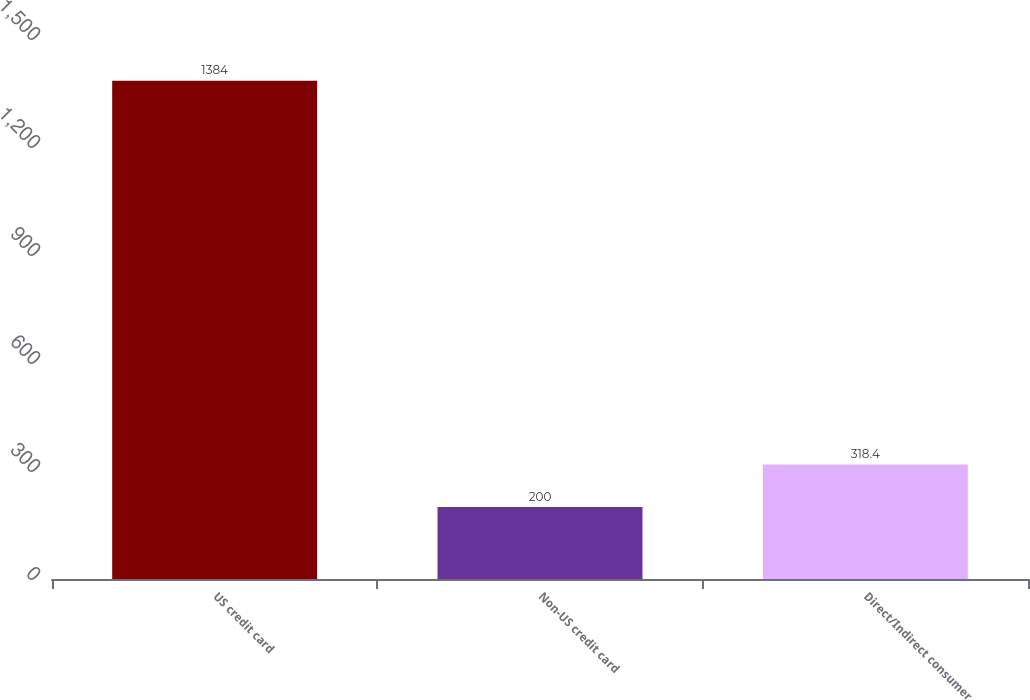Convert chart. <chart><loc_0><loc_0><loc_500><loc_500><bar_chart><fcel>US credit card<fcel>Non-US credit card<fcel>Direct/Indirect consumer<nl><fcel>1384<fcel>200<fcel>318.4<nl></chart> 